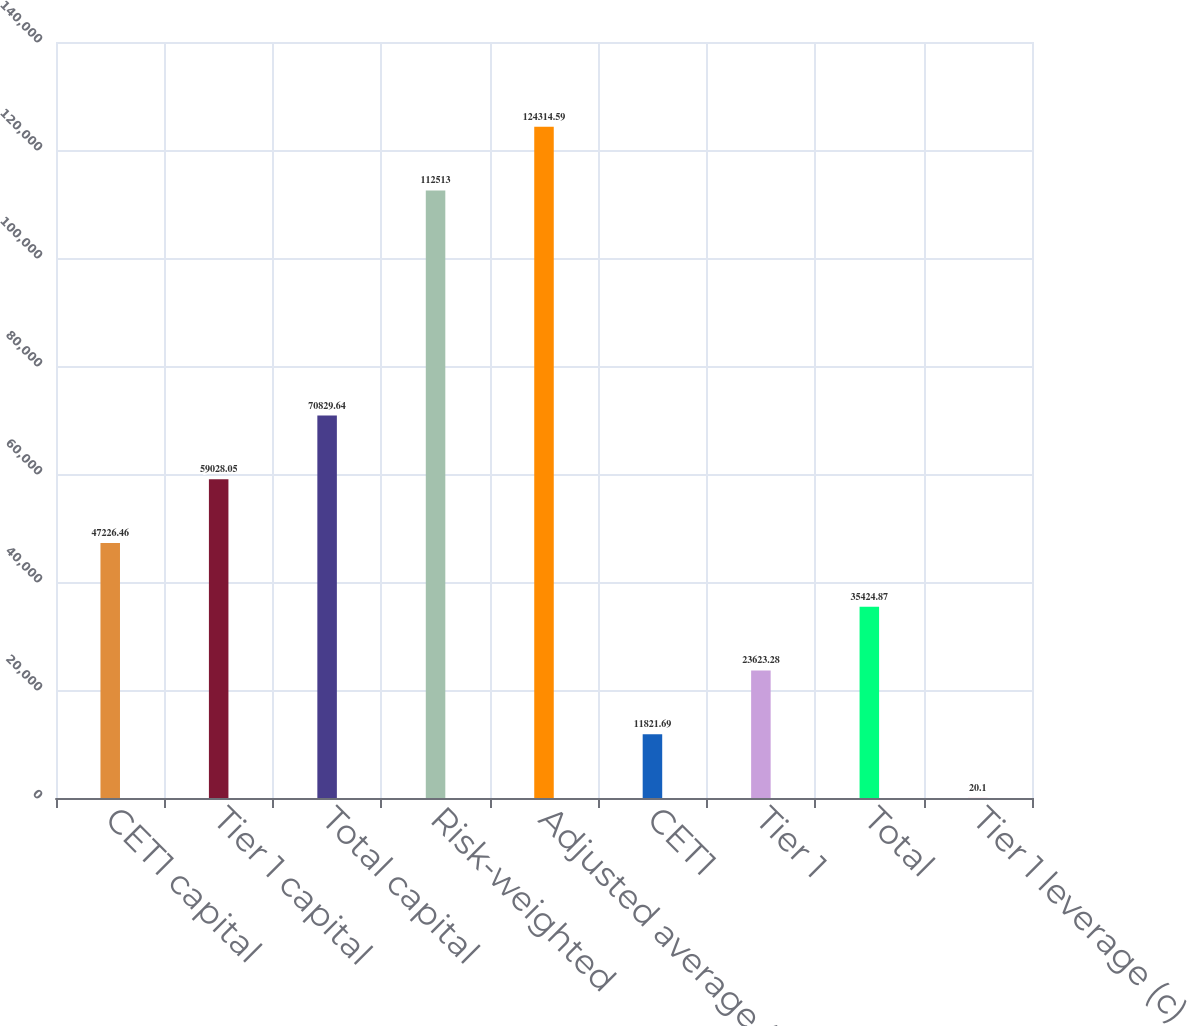Convert chart. <chart><loc_0><loc_0><loc_500><loc_500><bar_chart><fcel>CET1 capital<fcel>Tier 1 capital<fcel>Total capital<fcel>Risk-weighted<fcel>Adjusted average (a)<fcel>CET1<fcel>Tier 1<fcel>Total<fcel>Tier 1 leverage (c)<nl><fcel>47226.5<fcel>59028.1<fcel>70829.6<fcel>112513<fcel>124315<fcel>11821.7<fcel>23623.3<fcel>35424.9<fcel>20.1<nl></chart> 